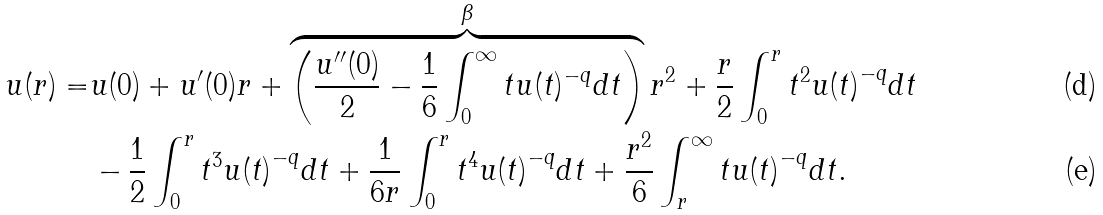Convert formula to latex. <formula><loc_0><loc_0><loc_500><loc_500>u ( r ) = & u ( 0 ) + u ^ { \prime } ( 0 ) r + \overbrace { \left ( { \frac { u ^ { \prime \prime } ( 0 ) } { 2 } - \frac { 1 } { 6 } \int _ { 0 } ^ { \infty } { t u ( t ) ^ { - q } d t } } \right ) } ^ { \beta } { r ^ { 2 } } + \frac { r } { 2 } \int _ { 0 } ^ { r } { { t ^ { 2 } } u { { ( t ) } ^ { - q } } d t } \\ & - \frac { 1 } { 2 } \int _ { 0 } ^ { r } { { t ^ { 3 } } u { { ( t ) } ^ { - q } } d t } + \frac { 1 } { 6 r } \int _ { 0 } ^ { r } { { t ^ { 4 } } u { { ( t ) } ^ { - q } } d t } + \frac { r ^ { 2 } } { 6 } \int _ { r } ^ { \infty } { t u { { ( t ) } ^ { - q } } d t } .</formula> 